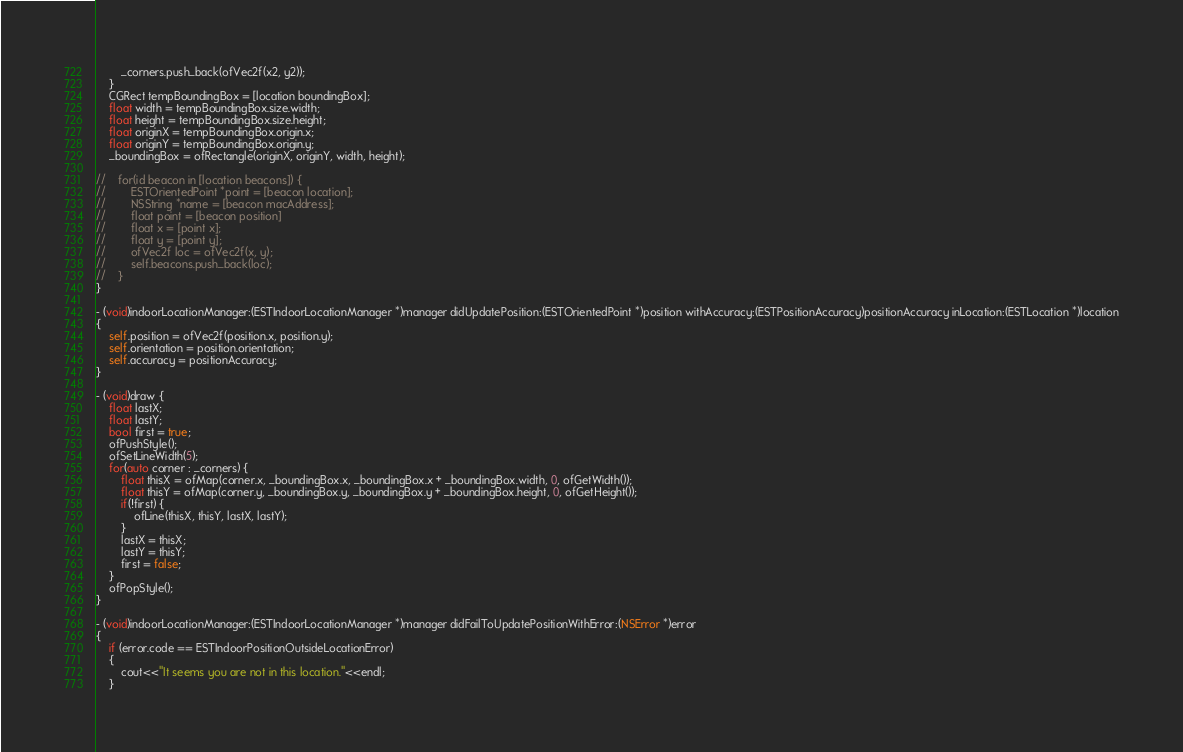Convert code to text. <code><loc_0><loc_0><loc_500><loc_500><_ObjectiveC_>        _corners.push_back(ofVec2f(x2, y2));
    }
    CGRect tempBoundingBox = [location boundingBox];
    float width = tempBoundingBox.size.width;
    float height = tempBoundingBox.size.height;
    float originX = tempBoundingBox.origin.x;
    float originY = tempBoundingBox.origin.y;
    _boundingBox = ofRectangle(originX, originY, width, height);
    
//    for(id beacon in [location beacons]) {
//        ESTOrientedPoint *point = [beacon location];
//        NSString *name = [beacon macAddress];
//        float point = [beacon position]
//        float x = [point x];
//        float y = [point y];
//        ofVec2f loc = ofVec2f(x, y);
//        self.beacons.push_back(loc);
//    }
}

- (void)indoorLocationManager:(ESTIndoorLocationManager *)manager didUpdatePosition:(ESTOrientedPoint *)position withAccuracy:(ESTPositionAccuracy)positionAccuracy inLocation:(ESTLocation *)location
{
    self.position = ofVec2f(position.x, position.y);
    self.orientation = position.orientation;
    self.accuracy = positionAccuracy;
}

- (void)draw {
    float lastX;
    float lastY;
    bool first = true;
    ofPushStyle();
    ofSetLineWidth(5);
    for(auto corner : _corners) {
        float thisX = ofMap(corner.x, _boundingBox.x, _boundingBox.x + _boundingBox.width, 0, ofGetWidth());
        float thisY = ofMap(corner.y, _boundingBox.y, _boundingBox.y + _boundingBox.height, 0, ofGetHeight());
        if(!first) {
            ofLine(thisX, thisY, lastX, lastY);
        }
        lastX = thisX;
        lastY = thisY;
        first = false;
    }
    ofPopStyle();
}

- (void)indoorLocationManager:(ESTIndoorLocationManager *)manager didFailToUpdatePositionWithError:(NSError *)error
{    
    if (error.code == ESTIndoorPositionOutsideLocationError)
    {
        cout<<"It seems you are not in this location."<<endl;
    }</code> 